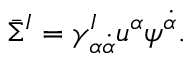Convert formula to latex. <formula><loc_0><loc_0><loc_500><loc_500>\bar { \Sigma } ^ { I } = \gamma _ { \alpha \dot { \alpha } } ^ { I } u ^ { \alpha } \psi ^ { \dot { \alpha } } .</formula> 